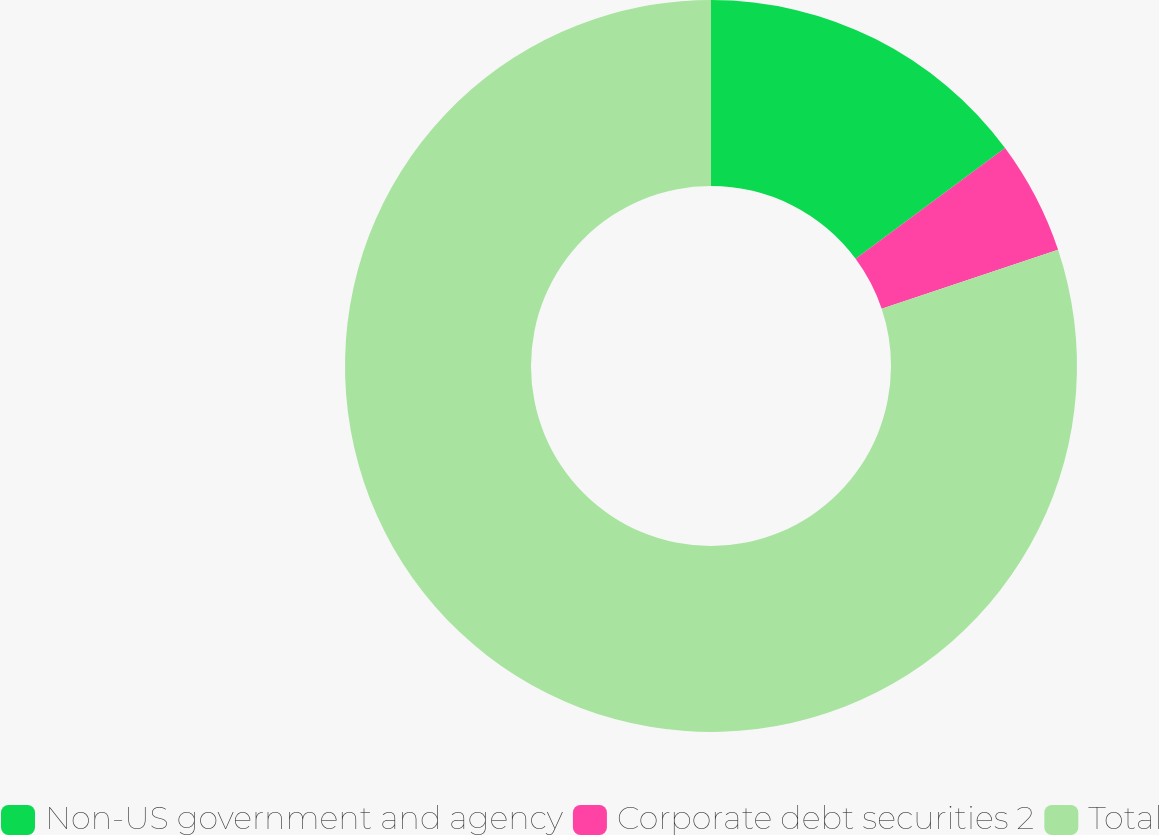Convert chart. <chart><loc_0><loc_0><loc_500><loc_500><pie_chart><fcel>Non-US government and agency<fcel>Corporate debt securities 2<fcel>Total<nl><fcel>14.85%<fcel>5.01%<fcel>80.14%<nl></chart> 